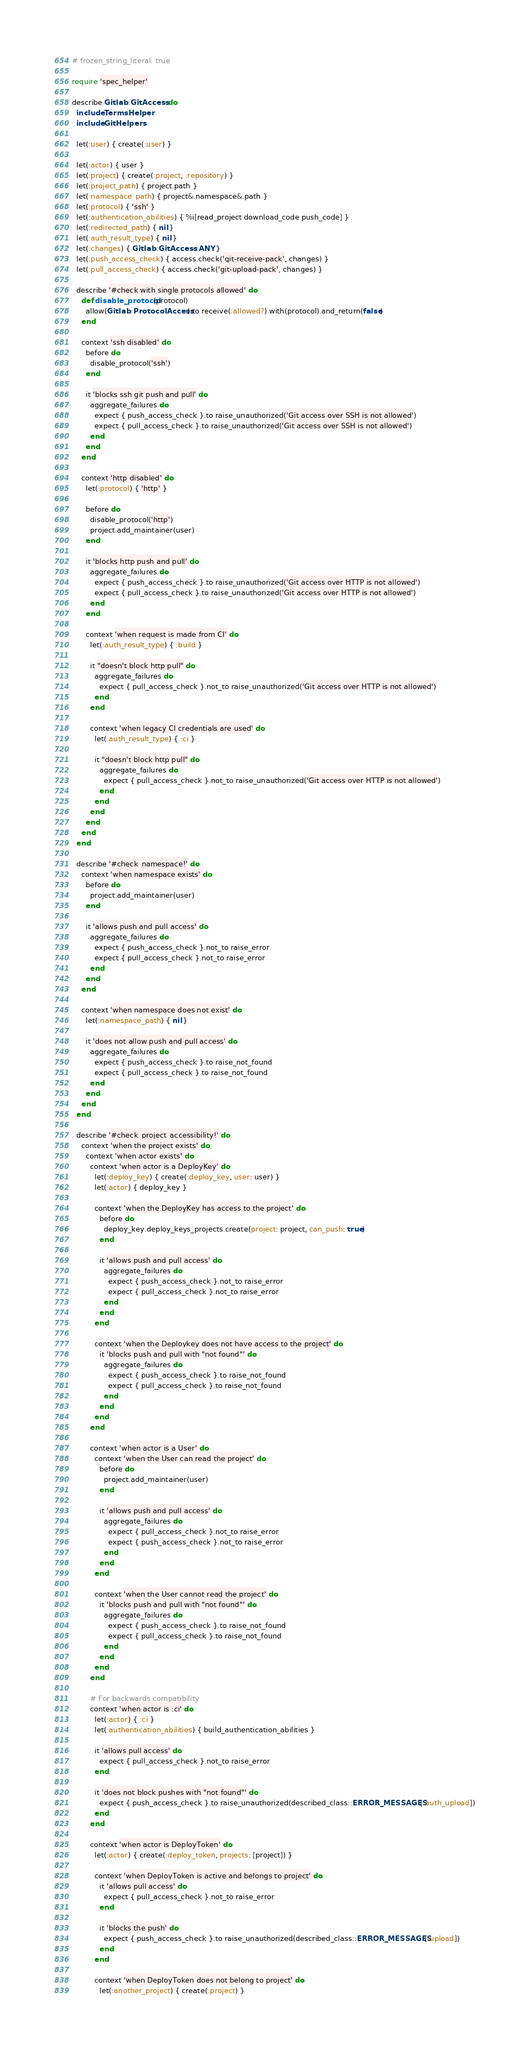<code> <loc_0><loc_0><loc_500><loc_500><_Ruby_># frozen_string_literal: true

require 'spec_helper'

describe Gitlab::GitAccess do
  include TermsHelper
  include GitHelpers

  let(:user) { create(:user) }

  let(:actor) { user }
  let(:project) { create(:project, :repository) }
  let(:project_path) { project.path }
  let(:namespace_path) { project&.namespace&.path }
  let(:protocol) { 'ssh' }
  let(:authentication_abilities) { %i[read_project download_code push_code] }
  let(:redirected_path) { nil }
  let(:auth_result_type) { nil }
  let(:changes) { Gitlab::GitAccess::ANY }
  let(:push_access_check) { access.check('git-receive-pack', changes) }
  let(:pull_access_check) { access.check('git-upload-pack', changes) }

  describe '#check with single protocols allowed' do
    def disable_protocol(protocol)
      allow(Gitlab::ProtocolAccess).to receive(:allowed?).with(protocol).and_return(false)
    end

    context 'ssh disabled' do
      before do
        disable_protocol('ssh')
      end

      it 'blocks ssh git push and pull' do
        aggregate_failures do
          expect { push_access_check }.to raise_unauthorized('Git access over SSH is not allowed')
          expect { pull_access_check }.to raise_unauthorized('Git access over SSH is not allowed')
        end
      end
    end

    context 'http disabled' do
      let(:protocol) { 'http' }

      before do
        disable_protocol('http')
        project.add_maintainer(user)
      end

      it 'blocks http push and pull' do
        aggregate_failures do
          expect { push_access_check }.to raise_unauthorized('Git access over HTTP is not allowed')
          expect { pull_access_check }.to raise_unauthorized('Git access over HTTP is not allowed')
        end
      end

      context 'when request is made from CI' do
        let(:auth_result_type) { :build }

        it "doesn't block http pull" do
          aggregate_failures do
            expect { pull_access_check }.not_to raise_unauthorized('Git access over HTTP is not allowed')
          end
        end

        context 'when legacy CI credentials are used' do
          let(:auth_result_type) { :ci }

          it "doesn't block http pull" do
            aggregate_failures do
              expect { pull_access_check }.not_to raise_unauthorized('Git access over HTTP is not allowed')
            end
          end
        end
      end
    end
  end

  describe '#check_namespace!' do
    context 'when namespace exists' do
      before do
        project.add_maintainer(user)
      end

      it 'allows push and pull access' do
        aggregate_failures do
          expect { push_access_check }.not_to raise_error
          expect { pull_access_check }.not_to raise_error
        end
      end
    end

    context 'when namespace does not exist' do
      let(:namespace_path) { nil }

      it 'does not allow push and pull access' do
        aggregate_failures do
          expect { push_access_check }.to raise_not_found
          expect { pull_access_check }.to raise_not_found
        end
      end
    end
  end

  describe '#check_project_accessibility!' do
    context 'when the project exists' do
      context 'when actor exists' do
        context 'when actor is a DeployKey' do
          let(:deploy_key) { create(:deploy_key, user: user) }
          let(:actor) { deploy_key }

          context 'when the DeployKey has access to the project' do
            before do
              deploy_key.deploy_keys_projects.create(project: project, can_push: true)
            end

            it 'allows push and pull access' do
              aggregate_failures do
                expect { push_access_check }.not_to raise_error
                expect { pull_access_check }.not_to raise_error
              end
            end
          end

          context 'when the Deploykey does not have access to the project' do
            it 'blocks push and pull with "not found"' do
              aggregate_failures do
                expect { push_access_check }.to raise_not_found
                expect { pull_access_check }.to raise_not_found
              end
            end
          end
        end

        context 'when actor is a User' do
          context 'when the User can read the project' do
            before do
              project.add_maintainer(user)
            end

            it 'allows push and pull access' do
              aggregate_failures do
                expect { pull_access_check }.not_to raise_error
                expect { push_access_check }.not_to raise_error
              end
            end
          end

          context 'when the User cannot read the project' do
            it 'blocks push and pull with "not found"' do
              aggregate_failures do
                expect { push_access_check }.to raise_not_found
                expect { pull_access_check }.to raise_not_found
              end
            end
          end
        end

        # For backwards compatibility
        context 'when actor is :ci' do
          let(:actor) { :ci }
          let(:authentication_abilities) { build_authentication_abilities }

          it 'allows pull access' do
            expect { pull_access_check }.not_to raise_error
          end

          it 'does not block pushes with "not found"' do
            expect { push_access_check }.to raise_unauthorized(described_class::ERROR_MESSAGES[:auth_upload])
          end
        end

        context 'when actor is DeployToken' do
          let(:actor) { create(:deploy_token, projects: [project]) }

          context 'when DeployToken is active and belongs to project' do
            it 'allows pull access' do
              expect { pull_access_check }.not_to raise_error
            end

            it 'blocks the push' do
              expect { push_access_check }.to raise_unauthorized(described_class::ERROR_MESSAGES[:upload])
            end
          end

          context 'when DeployToken does not belong to project' do
            let(:another_project) { create(:project) }</code> 